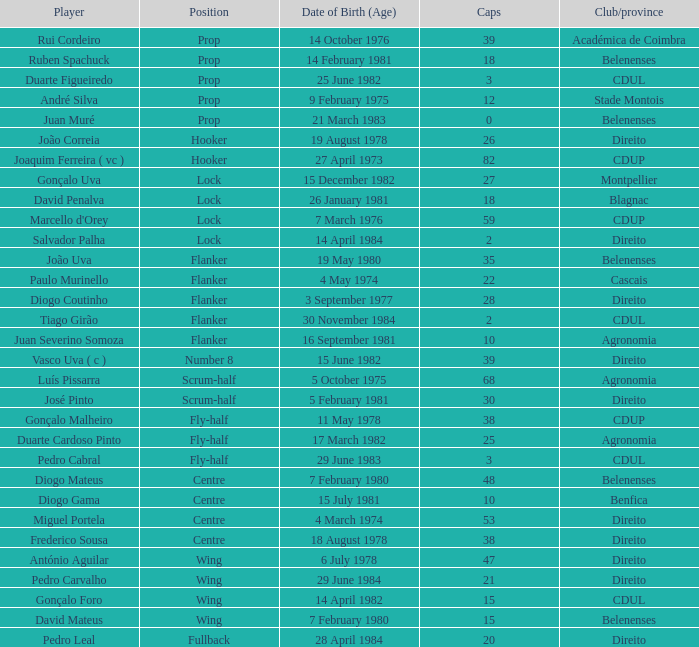Who is the player with a club/province of direito, under 21 caps, and holds the position of lock? Salvador Palha. 